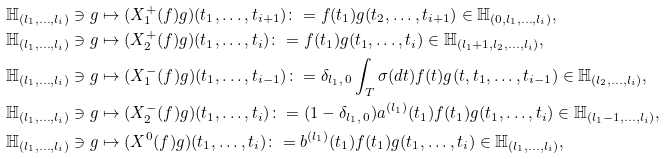Convert formula to latex. <formula><loc_0><loc_0><loc_500><loc_500>& \mathbb { H } _ { ( l _ { 1 } , \dots , l _ { i } ) } \ni g \mapsto ( X _ { 1 } ^ { + } ( f ) g ) ( t _ { 1 } , \dots , t _ { i + 1 } ) \colon = f ( t _ { 1 } ) g ( t _ { 2 } , \dots , t _ { i + 1 } ) \in \mathbb { H } _ { ( 0 , l _ { 1 } , \dots , l _ { i } ) } , \\ & \mathbb { H } _ { ( l _ { 1 } , \dots , l _ { i } ) } \ni g \mapsto ( X _ { 2 } ^ { + } ( f ) g ) ( t _ { 1 } , \dots , t _ { i } ) \colon = f ( t _ { 1 } ) g ( t _ { 1 } , \dots , t _ { i } ) \in \mathbb { H } _ { ( l _ { 1 } + 1 , l _ { 2 } , \dots , l _ { i } ) } , \\ & \mathbb { H } _ { ( l _ { 1 } , \dots , l _ { i } ) } \ni g \mapsto ( X _ { 1 } ^ { - } ( f ) g ) ( t _ { 1 } , \dots , t _ { i - 1 } ) \colon = \delta _ { l _ { 1 } , \, 0 } \int _ { T } \sigma ( d t ) f ( t ) g ( t , t _ { 1 } , \dots , t _ { i - 1 } ) \in \mathbb { H } _ { ( l _ { 2 } , \dots , l _ { i } ) } , \\ & \mathbb { H } _ { ( l _ { 1 } , \dots , l _ { i } ) } \ni g \mapsto ( X _ { 2 } ^ { - } ( f ) g ) ( t _ { 1 } , \dots , t _ { i } ) \colon = ( 1 - \delta _ { l _ { 1 } , \, 0 } ) a ^ { ( l _ { 1 } ) } ( t _ { 1 } ) f ( t _ { 1 } ) g ( t _ { 1 } , \dots , t _ { i } ) \in \mathbb { H } _ { ( l _ { 1 } - 1 , \dots , l _ { i } ) } , \\ & \mathbb { H } _ { ( l _ { 1 } , \dots , l _ { i } ) } \ni g \mapsto ( X ^ { 0 } ( f ) g ) ( t _ { 1 } , \dots , t _ { i } ) \colon = b ^ { ( l _ { 1 } ) } ( t _ { 1 } ) f ( t _ { 1 } ) g ( t _ { 1 } , \dots , t _ { i } ) \in \mathbb { H } _ { ( l _ { 1 } , \dots , l _ { i } ) } ,</formula> 